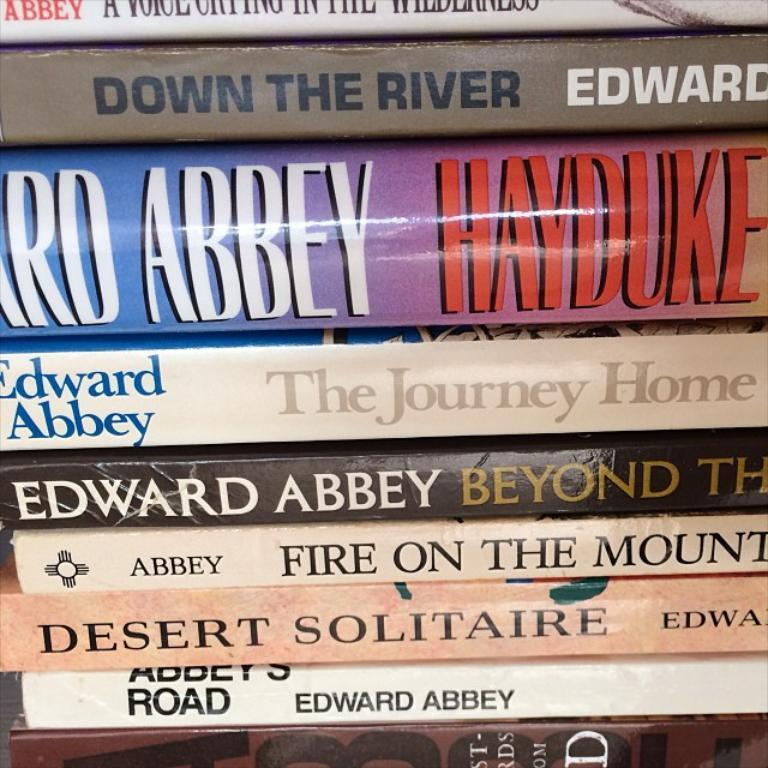<image>
Present a compact description of the photo's key features. Stack of books with one that says Edward abbey. 